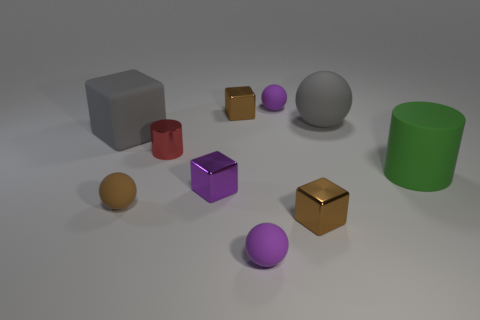How many other things are there of the same size as the matte cylinder?
Provide a succinct answer. 2. What number of things are brown objects behind the green matte object or things right of the purple metal block?
Offer a very short reply. 6. How many gray matte objects have the same shape as the small purple metallic thing?
Your answer should be very brief. 1. The sphere that is both left of the big matte sphere and behind the matte cube is made of what material?
Ensure brevity in your answer.  Rubber. There is a large green cylinder; what number of tiny blocks are in front of it?
Offer a very short reply. 2. What number of purple shiny cubes are there?
Keep it short and to the point. 1. Does the purple block have the same size as the matte cube?
Make the answer very short. No. Is there a gray matte cube behind the large gray matte object that is to the left of the brown thing that is left of the small red shiny thing?
Your answer should be compact. No. There is another object that is the same shape as the large green rubber thing; what material is it?
Keep it short and to the point. Metal. What is the color of the big object in front of the gray matte cube?
Keep it short and to the point. Green. 